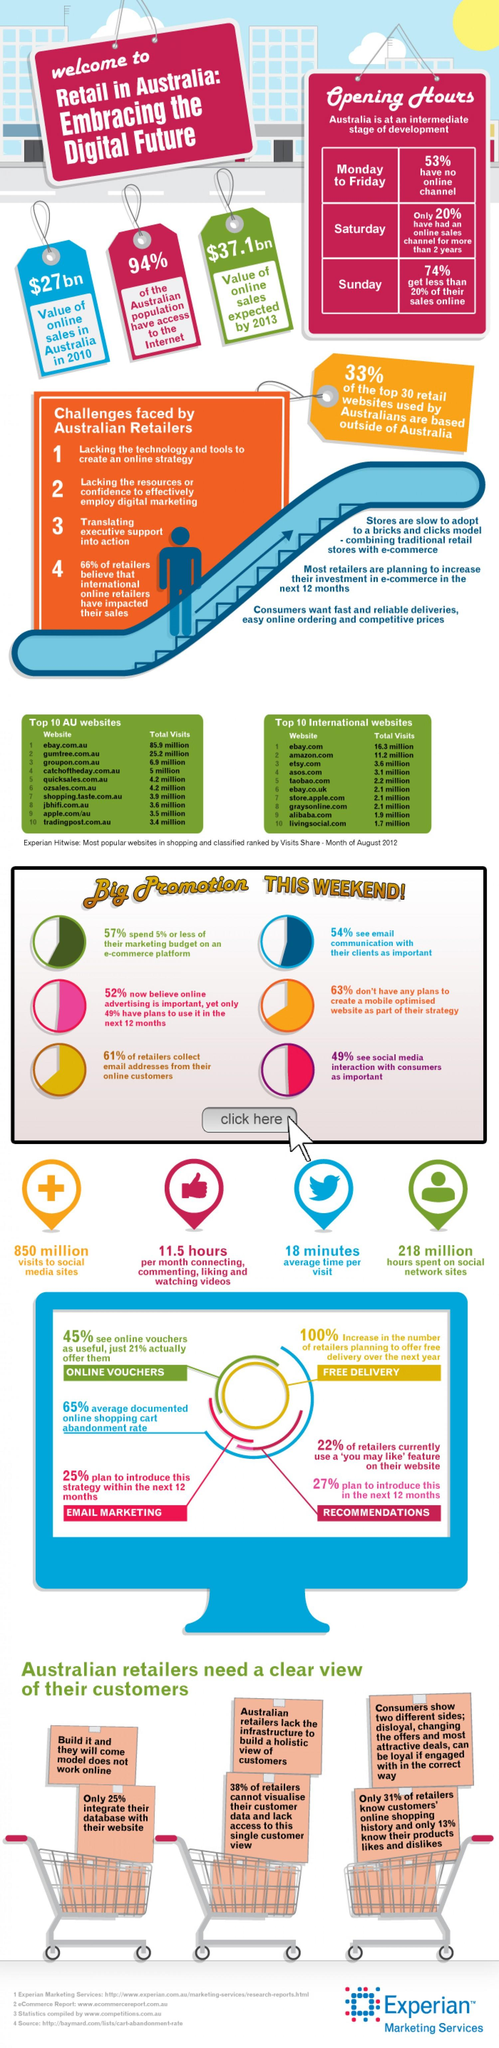Highlight a few significant elements in this photo. The website that is most frequently accessed by Australians is eBay. According to a recent survey, 61% of retailers collect email addresses from their online customers. According to recent statistics, a vast majority of the Australian population, approximately 94%, has access to the internet. According to a recent survey, 33% of the top 30 retail websites used by Australians are based outside of Australia. LivingSocial.com is the least visited international website. 